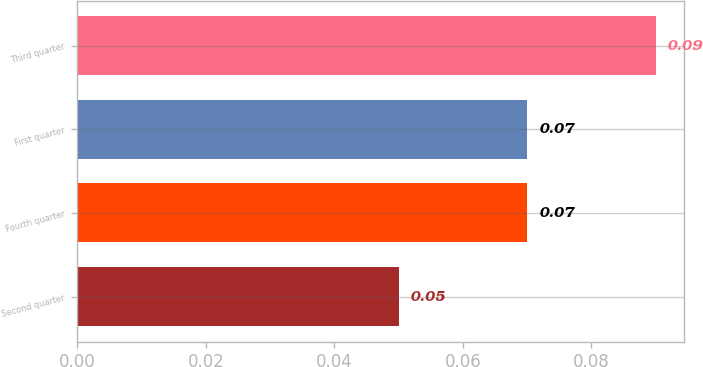Convert chart to OTSL. <chart><loc_0><loc_0><loc_500><loc_500><bar_chart><fcel>Second quarter<fcel>Fourth quarter<fcel>First quarter<fcel>Third quarter<nl><fcel>0.05<fcel>0.07<fcel>0.07<fcel>0.09<nl></chart> 